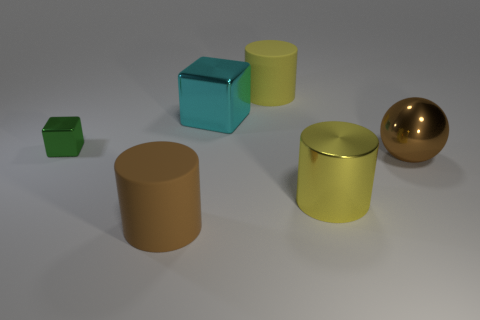Can you tell me the colors of the objects in the scene and count how many objects share the same colors? Certainly! In the scene, we have a golden sphere, two brown objects (one cube and one cylinder), a green small cube, a green large cube, a blue cube, and a yellow-green cylinder. So to break it down by color: there are two green objects (if we consider the yellow-green to be a shade of green), one blue object, two brown objects, and one golden object.  Which object stands out the most and why? The golden sphere stands out the most due to its reflective surface which contrasts with the matte finishes of the other objects. It also differs in shape from the cubes and cylinders that dominate the scene, making it a distinct visual element. 